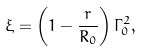Convert formula to latex. <formula><loc_0><loc_0><loc_500><loc_500>\xi = \left ( 1 - \frac { r } { R _ { 0 } } \right ) \Gamma _ { 0 } ^ { 2 } ,</formula> 